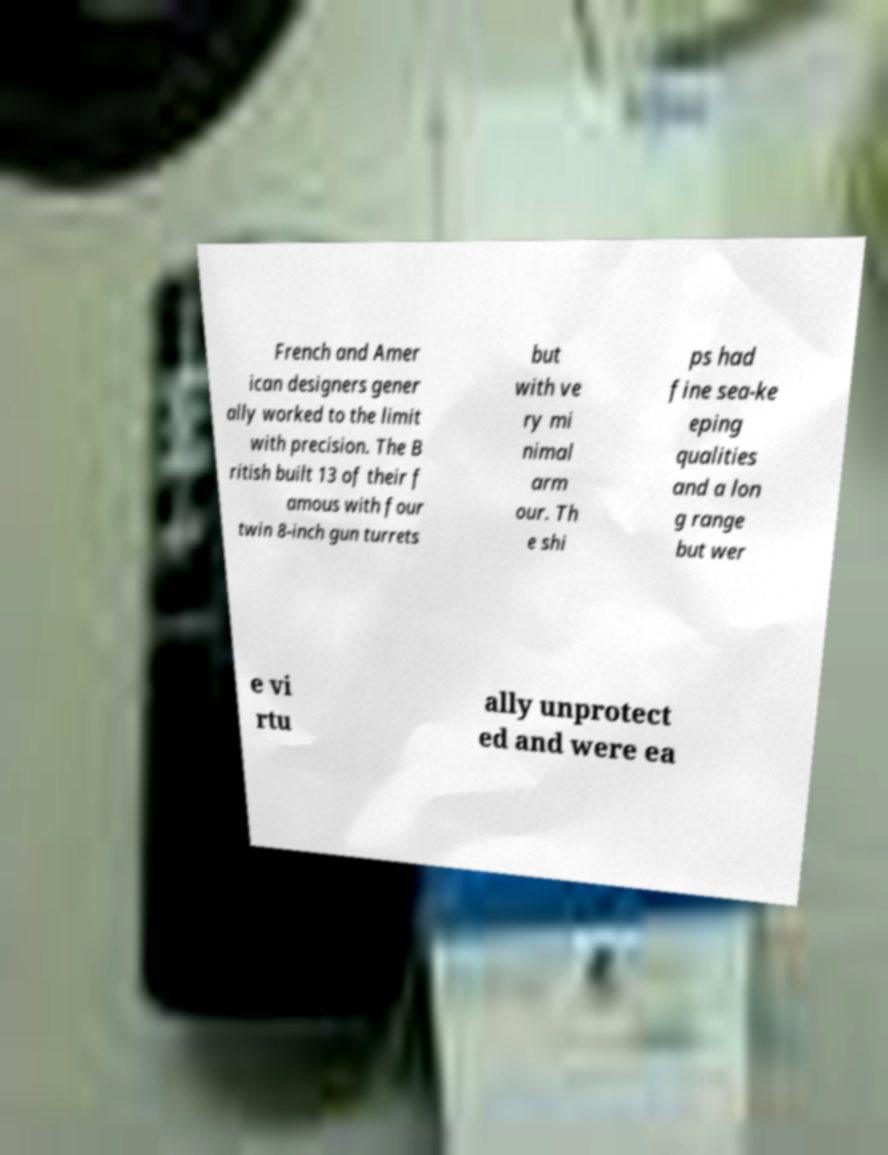Could you assist in decoding the text presented in this image and type it out clearly? French and Amer ican designers gener ally worked to the limit with precision. The B ritish built 13 of their f amous with four twin 8-inch gun turrets but with ve ry mi nimal arm our. Th e shi ps had fine sea-ke eping qualities and a lon g range but wer e vi rtu ally unprotect ed and were ea 